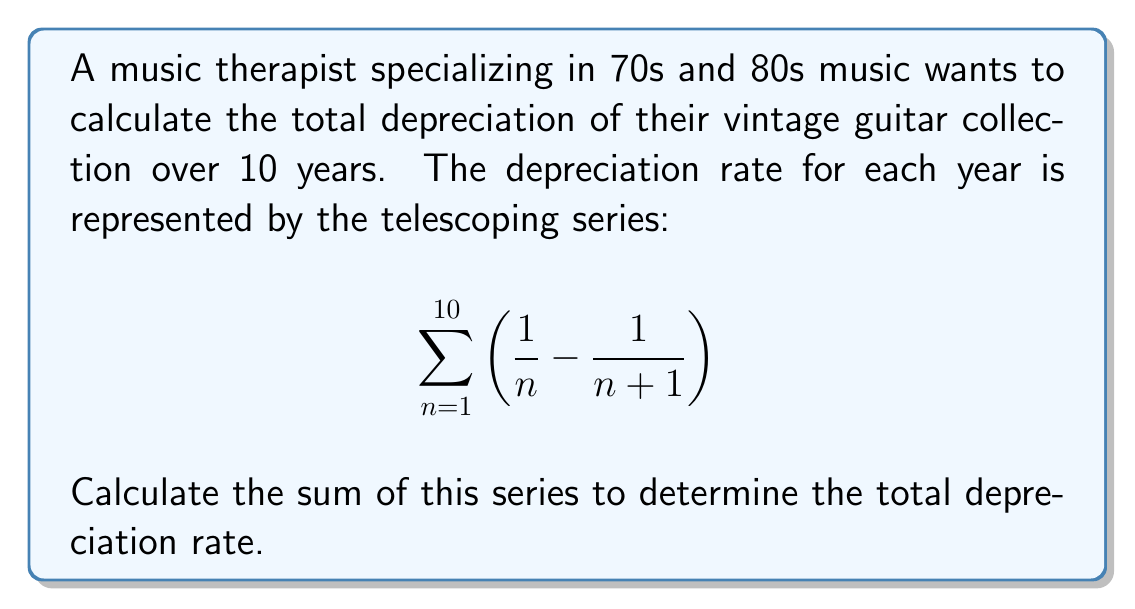Provide a solution to this math problem. Let's approach this step-by-step:

1) The general term of the series is $\frac{1}{n} - \frac{1}{n+1}$

2) Let's write out the first few terms:
   $$\left(\frac{1}{1} - \frac{1}{2}\right) + \left(\frac{1}{2} - \frac{1}{3}\right) + \left(\frac{1}{3} - \frac{1}{4}\right) + ... + \left(\frac{1}{9} - \frac{1}{10}\right) + \left(\frac{1}{10} - \frac{1}{11}\right)$$

3) Notice how the fractions cancel out except for the first and last terms:
   $$1 - \frac{1}{11}$$

4) This is because each $\frac{1}{n}$ term (except the first) is canceled by the $-\frac{1}{n}$ in the previous parenthesis.

5) Therefore, the sum of this telescoping series is:
   $$1 - \frac{1}{11} = \frac{11}{11} - \frac{1}{11} = \frac{10}{11}$$

6) This means the total depreciation rate over 10 years is $\frac{10}{11}$ or approximately 90.91%.
Answer: $\frac{10}{11}$ 